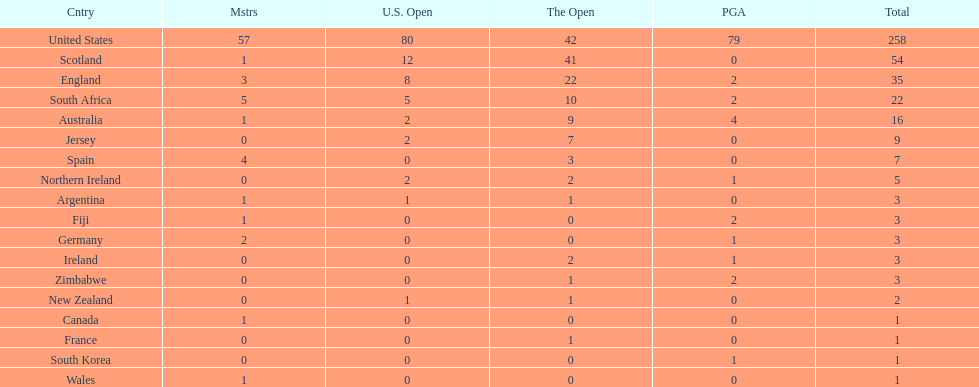Is the united stated or scotland better? United States. 